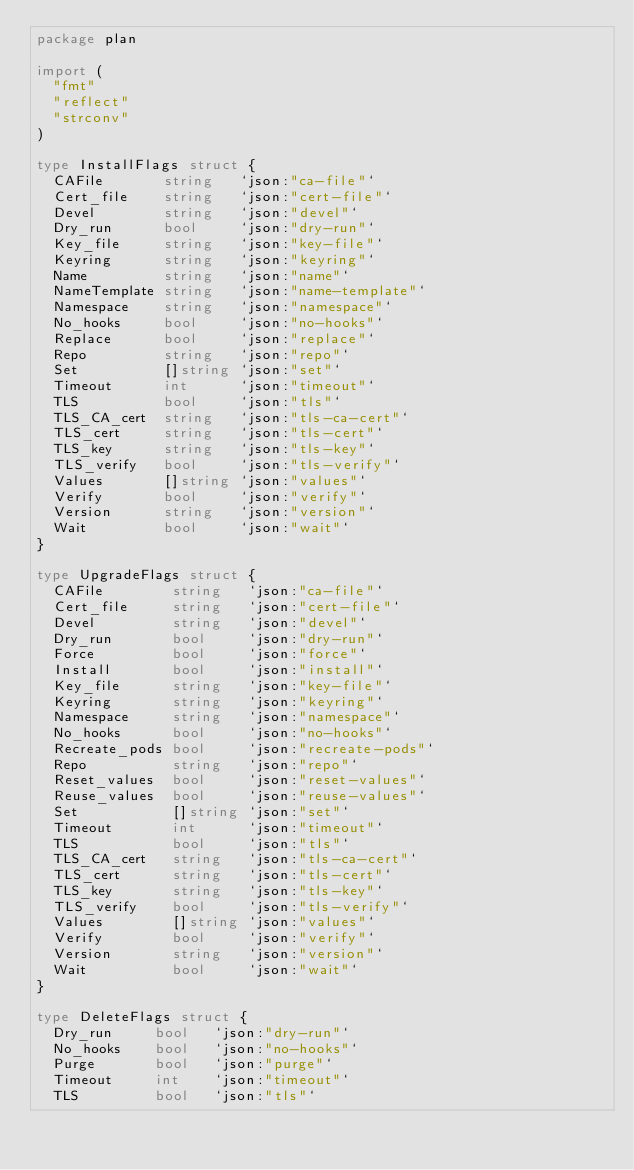Convert code to text. <code><loc_0><loc_0><loc_500><loc_500><_Go_>package plan

import (
	"fmt"
	"reflect"
	"strconv"
)

type InstallFlags struct {
	CAFile       string   `json:"ca-file"`
	Cert_file    string   `json:"cert-file"`
	Devel        string   `json:"devel"`
	Dry_run      bool     `json:"dry-run"`
	Key_file     string   `json:"key-file"`
	Keyring      string   `json:"keyring"`
	Name         string   `json:"name"`
	NameTemplate string   `json:"name-template"`
	Namespace    string   `json:"namespace"`
	No_hooks     bool     `json:"no-hooks"`
	Replace      bool     `json:"replace"`
	Repo         string   `json:"repo"`
	Set          []string `json:"set"`
	Timeout      int      `json:"timeout"`
	TLS          bool     `json:"tls"`
	TLS_CA_cert  string   `json:"tls-ca-cert"`
	TLS_cert     string   `json:"tls-cert"`
	TLS_key      string   `json:"tls-key"`
	TLS_verify   bool     `json:"tls-verify"`
	Values       []string `json:"values"`
	Verify       bool     `json:"verify"`
	Version      string   `json:"version"`
	Wait         bool     `json:"wait"`
}

type UpgradeFlags struct {
	CAFile        string   `json:"ca-file"`
	Cert_file     string   `json:"cert-file"`
	Devel         string   `json:"devel"`
	Dry_run       bool     `json:"dry-run"`
	Force         bool     `json:"force"`
	Install       bool     `json:"install"`
	Key_file      string   `json:"key-file"`
	Keyring       string   `json:"keyring"`
	Namespace     string   `json:"namespace"`
	No_hooks      bool     `json:"no-hooks"`
	Recreate_pods bool     `json:"recreate-pods"`
	Repo          string   `json:"repo"`
	Reset_values  bool     `json:"reset-values"`
	Reuse_values  bool     `json:"reuse-values"`
	Set           []string `json:"set"`
	Timeout       int      `json:"timeout"`
	TLS           bool     `json:"tls"`
	TLS_CA_cert   string   `json:"tls-ca-cert"`
	TLS_cert      string   `json:"tls-cert"`
	TLS_key       string   `json:"tls-key"`
	TLS_verify    bool     `json:"tls-verify"`
	Values        []string `json:"values"`
	Verify        bool     `json:"verify"`
	Version       string   `json:"version"`
	Wait          bool     `json:"wait"`
}

type DeleteFlags struct {
	Dry_run     bool   `json:"dry-run"`
	No_hooks    bool   `json:"no-hooks"`
	Purge       bool   `json:"purge"`
	Timeout     int    `json:"timeout"`
	TLS         bool   `json:"tls"`</code> 